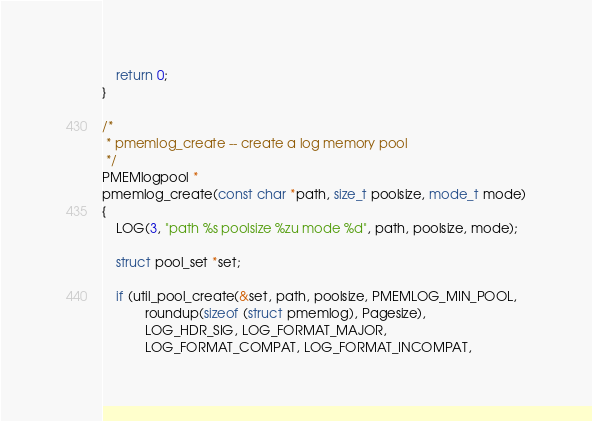<code> <loc_0><loc_0><loc_500><loc_500><_C_>
	return 0;
}

/*
 * pmemlog_create -- create a log memory pool
 */
PMEMlogpool *
pmemlog_create(const char *path, size_t poolsize, mode_t mode)
{
	LOG(3, "path %s poolsize %zu mode %d", path, poolsize, mode);

	struct pool_set *set;

	if (util_pool_create(&set, path, poolsize, PMEMLOG_MIN_POOL,
			roundup(sizeof (struct pmemlog), Pagesize),
			LOG_HDR_SIG, LOG_FORMAT_MAJOR,
			LOG_FORMAT_COMPAT, LOG_FORMAT_INCOMPAT,</code> 